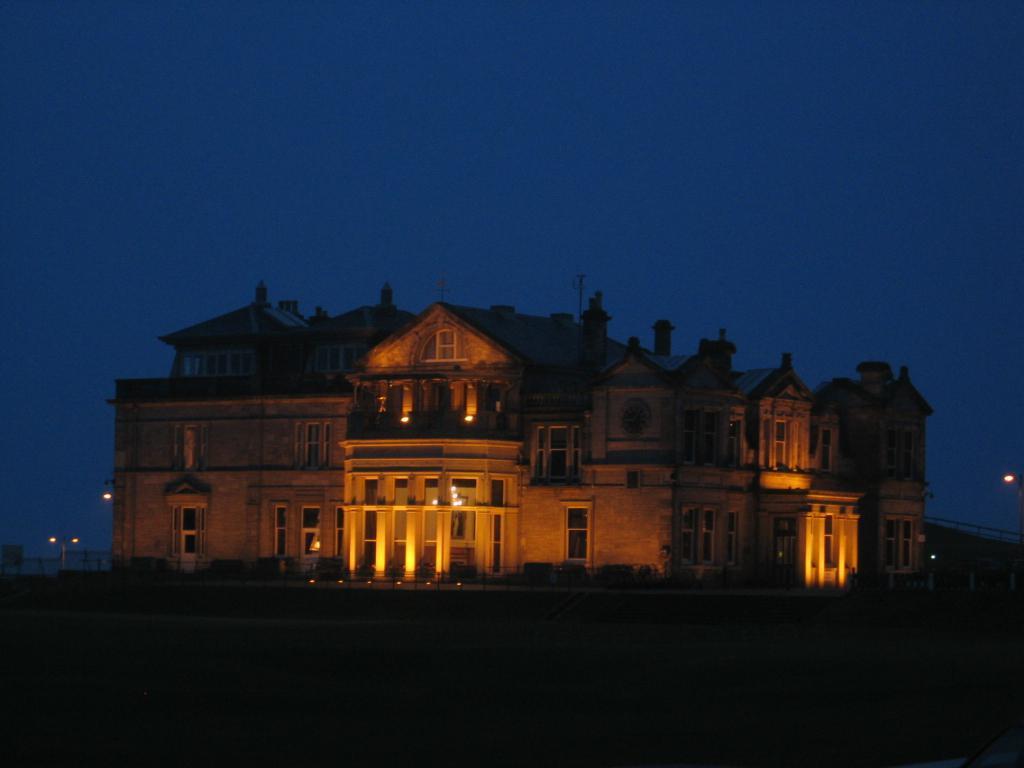Could you give a brief overview of what you see in this image? The image is captured in the night time it is a beautiful palace with a lot of windows and doors,there are some lights in front of the doors of palace. in the background there is a sky. 